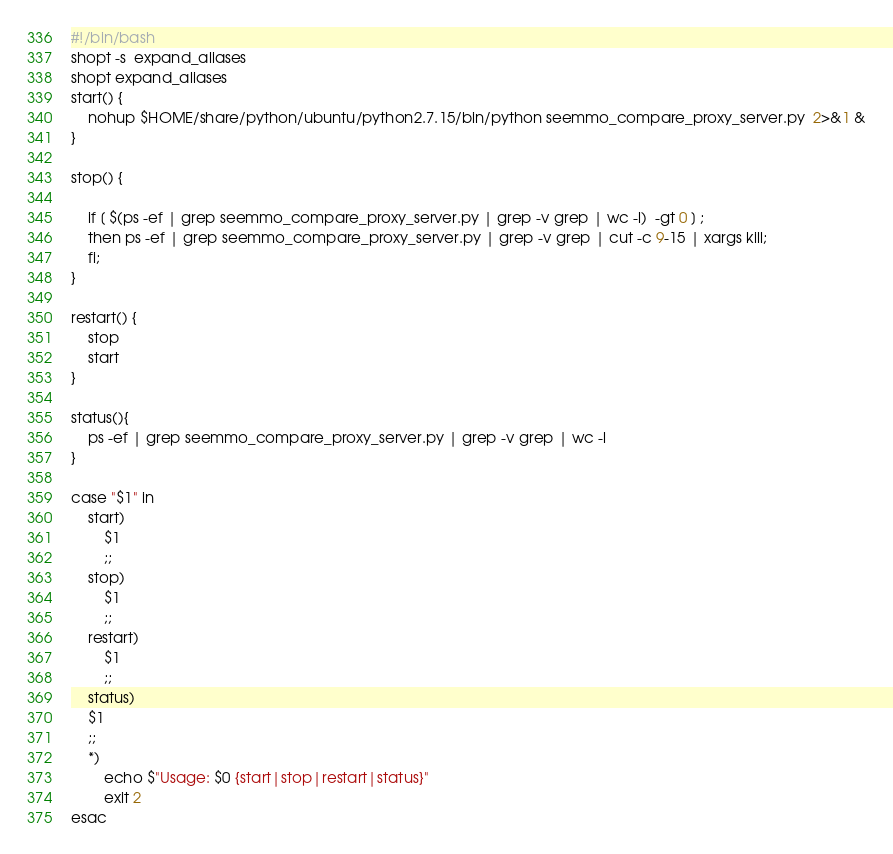<code> <loc_0><loc_0><loc_500><loc_500><_Bash_>#!/bin/bash
shopt -s  expand_aliases
shopt expand_aliases
start() {
    nohup $HOME/share/python/ubuntu/python2.7.15/bin/python seemmo_compare_proxy_server.py  2>&1 &
}

stop() {

    if [ $(ps -ef | grep seemmo_compare_proxy_server.py | grep -v grep | wc -l)  -gt 0 ] ;
    then ps -ef | grep seemmo_compare_proxy_server.py | grep -v grep | cut -c 9-15 | xargs kill;
    fi;
}

restart() {
    stop
    start
}

status(){
    ps -ef | grep seemmo_compare_proxy_server.py | grep -v grep | wc -l
}

case "$1" in
    start)
        $1
        ;;
    stop)
        $1
        ;;
    restart)
        $1
        ;;
    status)
    $1
    ;;
    *)
        echo $"Usage: $0 {start|stop|restart|status}"
        exit 2
esac
</code> 